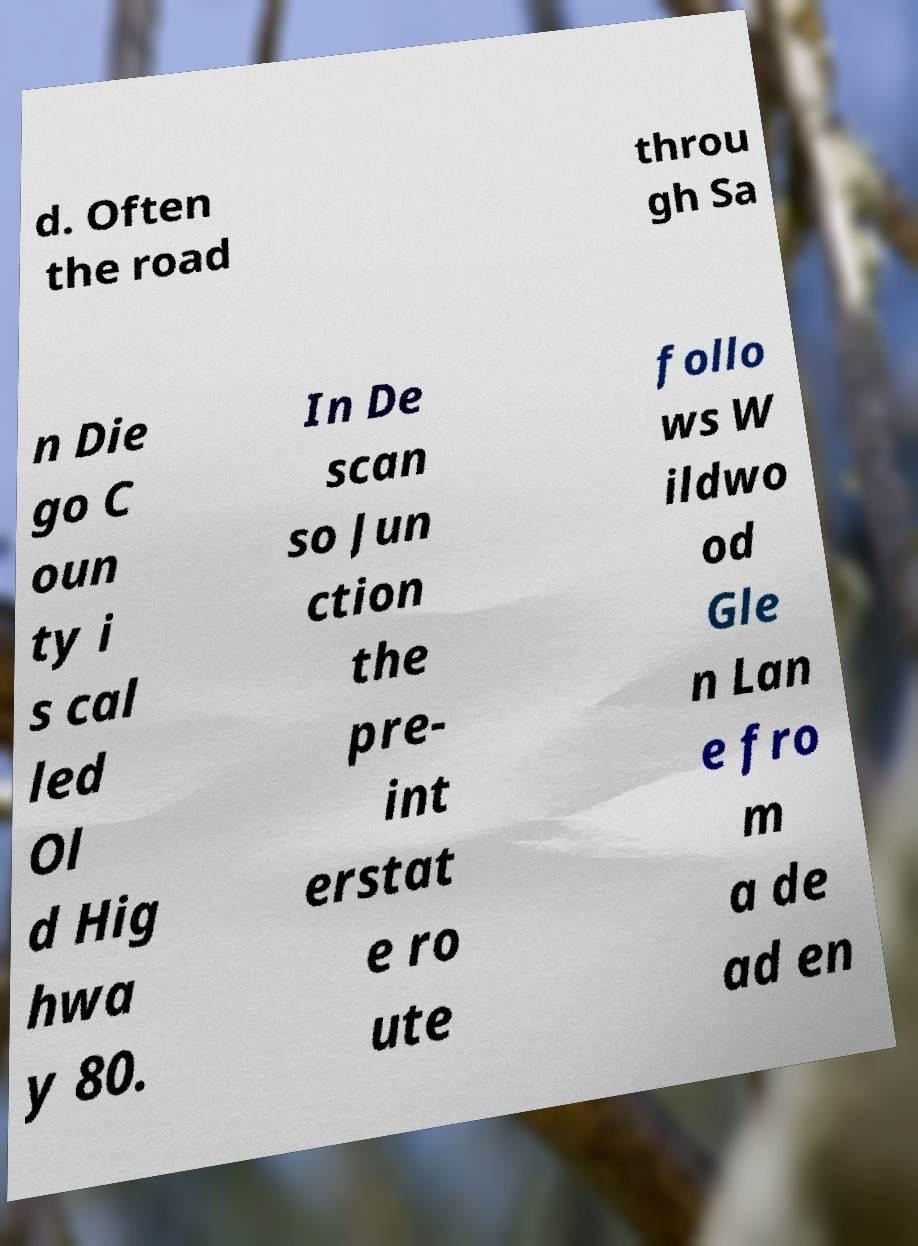Please identify and transcribe the text found in this image. d. Often the road throu gh Sa n Die go C oun ty i s cal led Ol d Hig hwa y 80. In De scan so Jun ction the pre- int erstat e ro ute follo ws W ildwo od Gle n Lan e fro m a de ad en 